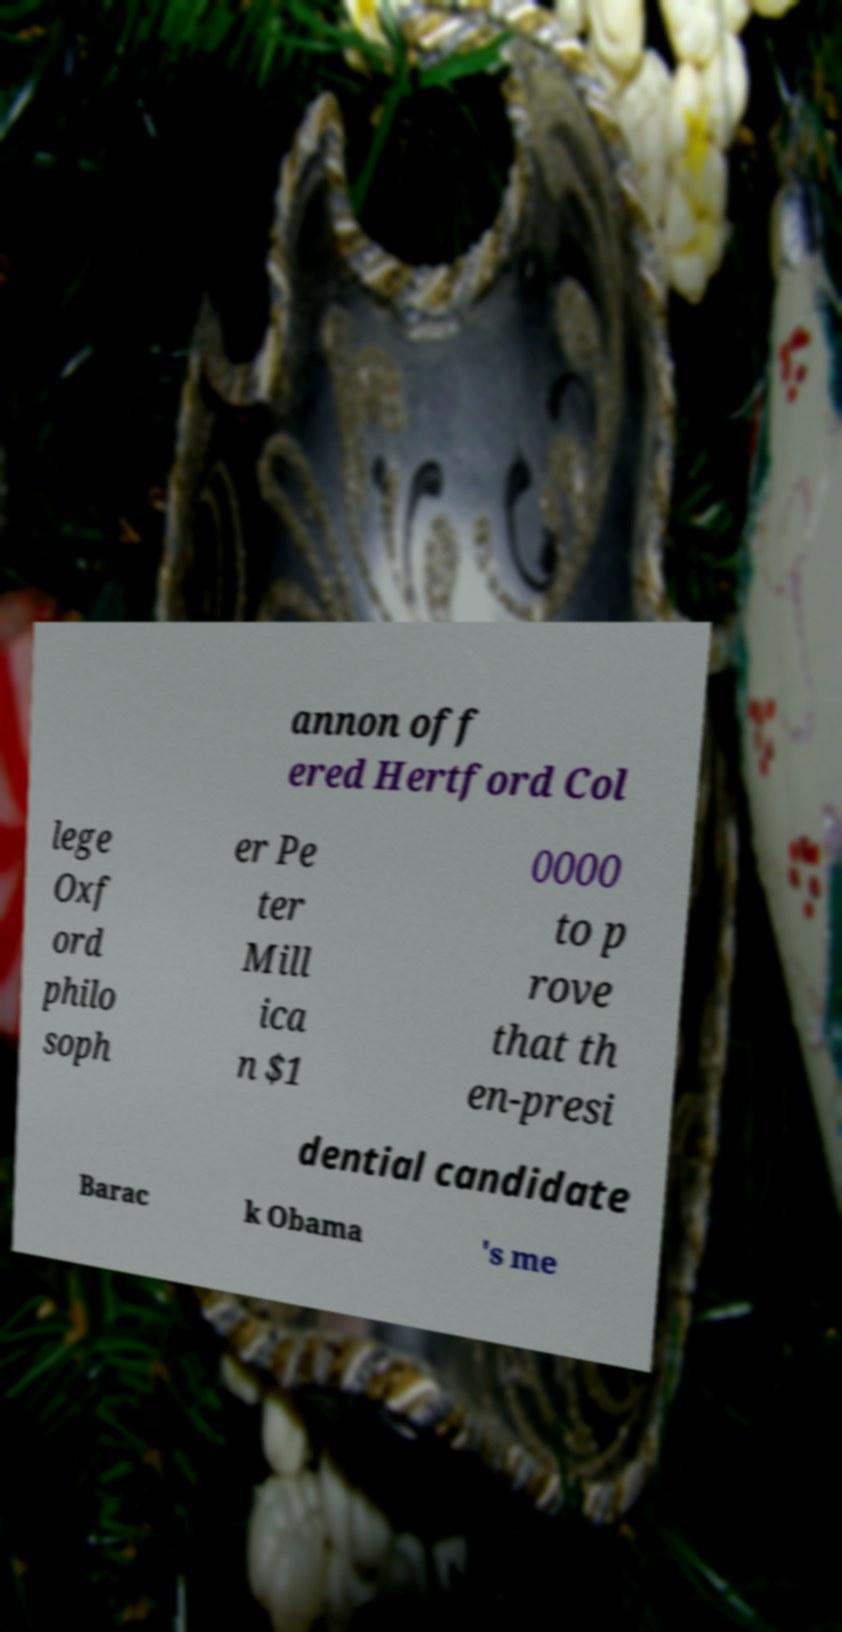Could you assist in decoding the text presented in this image and type it out clearly? annon off ered Hertford Col lege Oxf ord philo soph er Pe ter Mill ica n $1 0000 to p rove that th en-presi dential candidate Barac k Obama 's me 